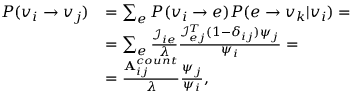Convert formula to latex. <formula><loc_0><loc_0><loc_500><loc_500>\begin{array} { r l } { P ( v _ { i } \rightarrow v _ { j } ) } & { = \sum _ { e } P ( v _ { i } \rightarrow e ) P ( e \rightarrow v _ { k } | v _ { i } ) = } \\ & { = \sum _ { e } \frac { \mathcal { I } _ { i e } } { \lambda } \frac { \mathcal { I } _ { e j } ^ { T } ( 1 - \delta _ { i j } ) \psi _ { j } } { \psi _ { i } } = } \\ & { = \frac { A _ { i j } ^ { c o u n t } } { \lambda } \frac { \psi _ { j } } { \psi _ { i } } , } \end{array}</formula> 